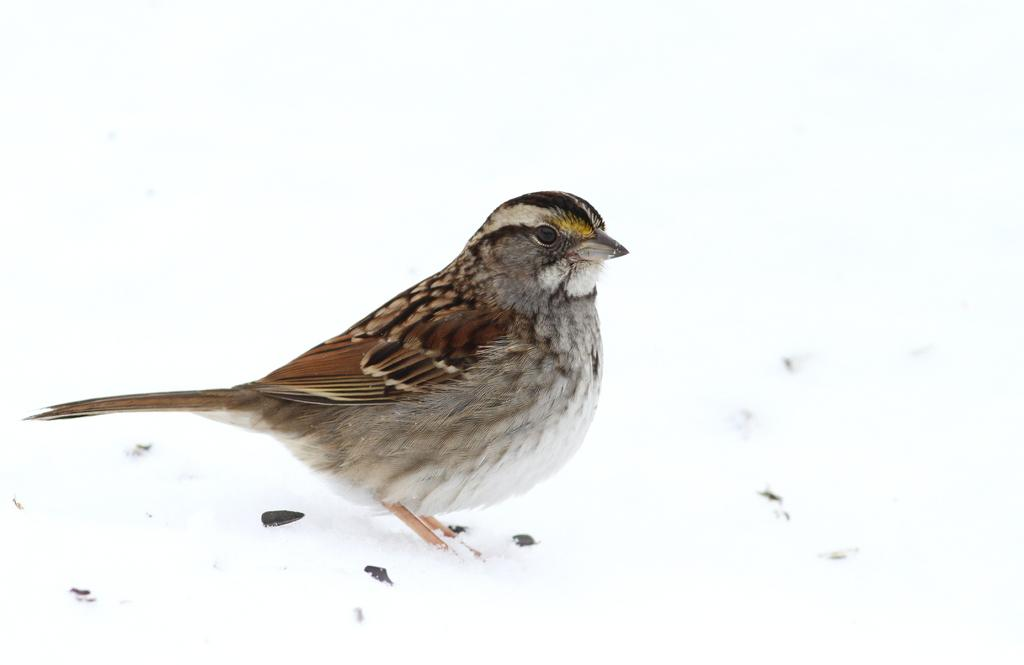What type of animal is on the ground in the image? There is a bird on the ground in the image. What is covering the ground in the image? There is snow on the ground in the image. What effect does the bird have on the approval rating of the local government in the image? There is no information about the local government or approval ratings in the image, so it cannot be determined. 